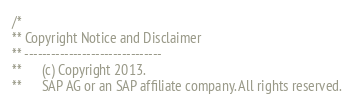Convert code to text. <code><loc_0><loc_0><loc_500><loc_500><_C_>/*
** Copyright Notice and Disclaimer
** -------------------------------
**      (c) Copyright 2013.
**      SAP AG or an SAP affiliate company. All rights reserved.</code> 